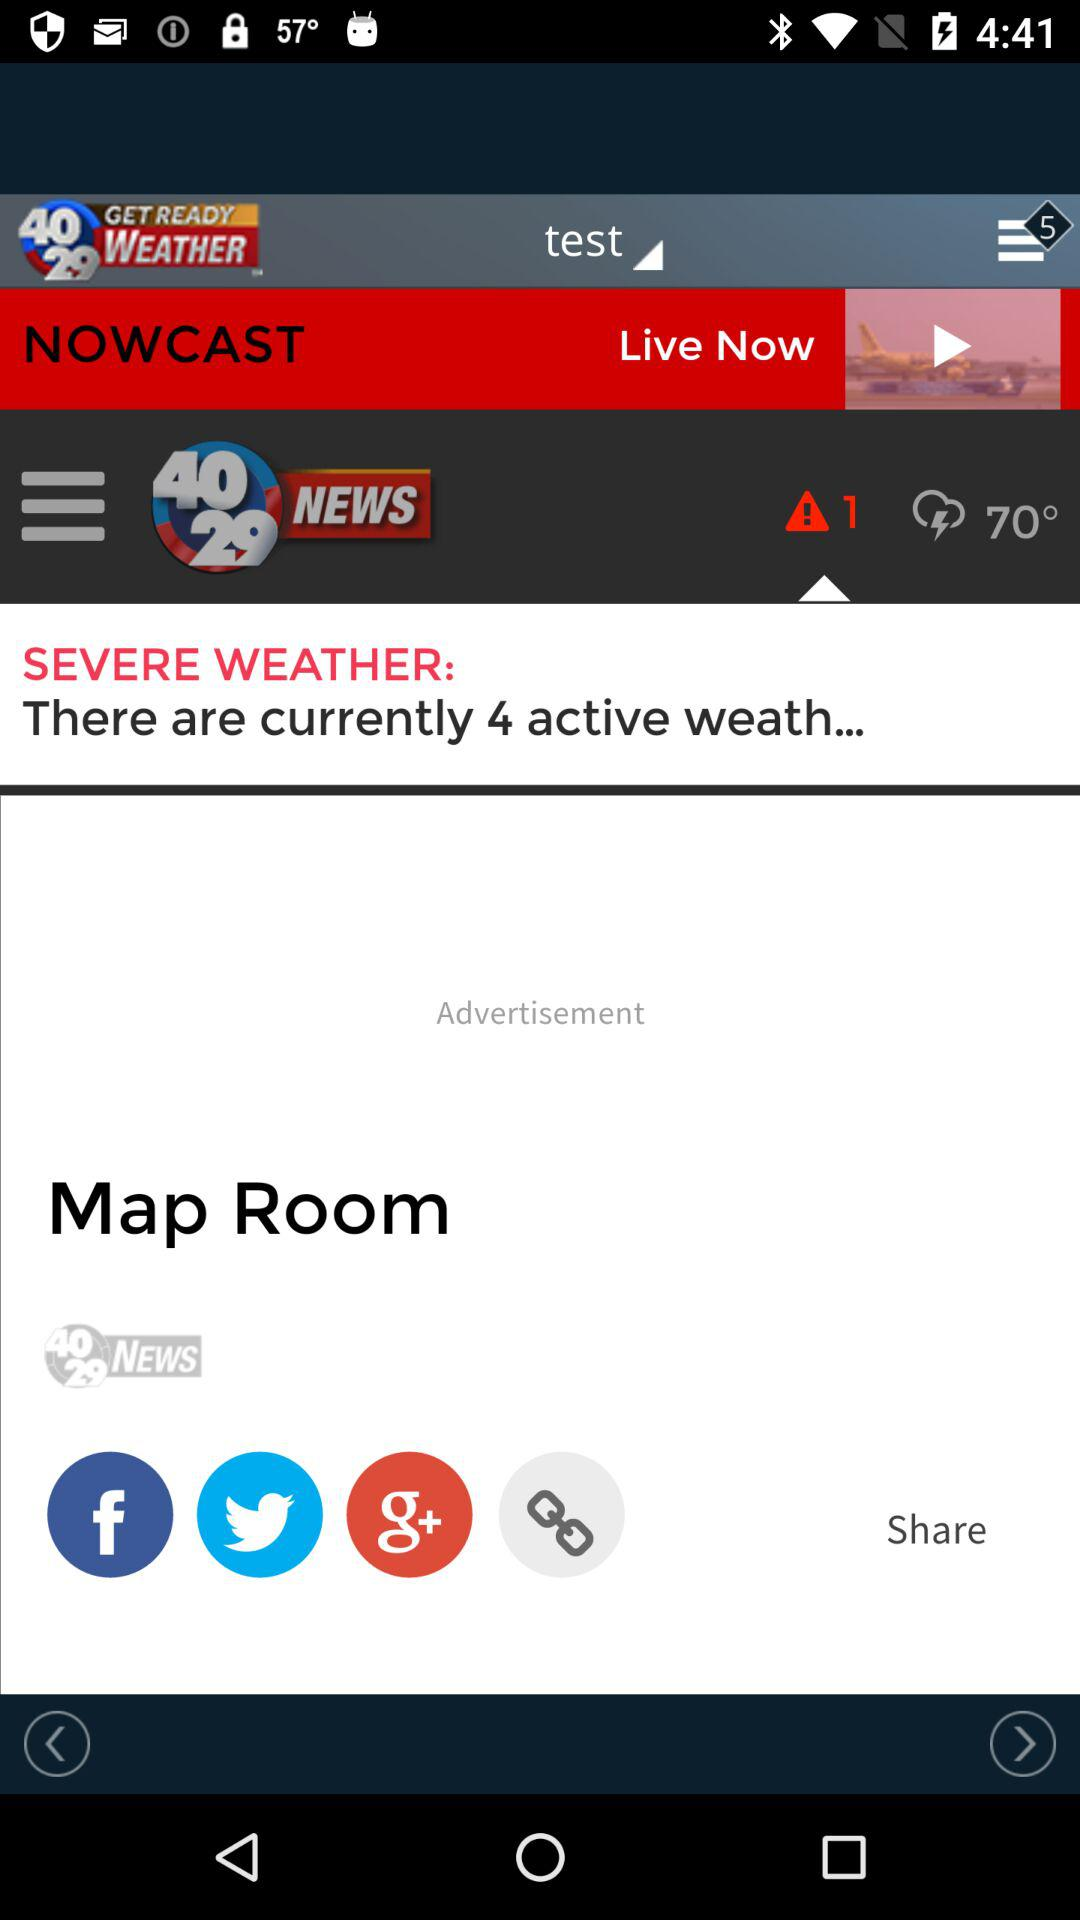What's the temperature? The temperature is 70°. 